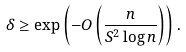<formula> <loc_0><loc_0><loc_500><loc_500>\delta & \geq \exp \left ( - O \left ( \frac { n } { S ^ { 2 } \log n } \right ) \right ) .</formula> 